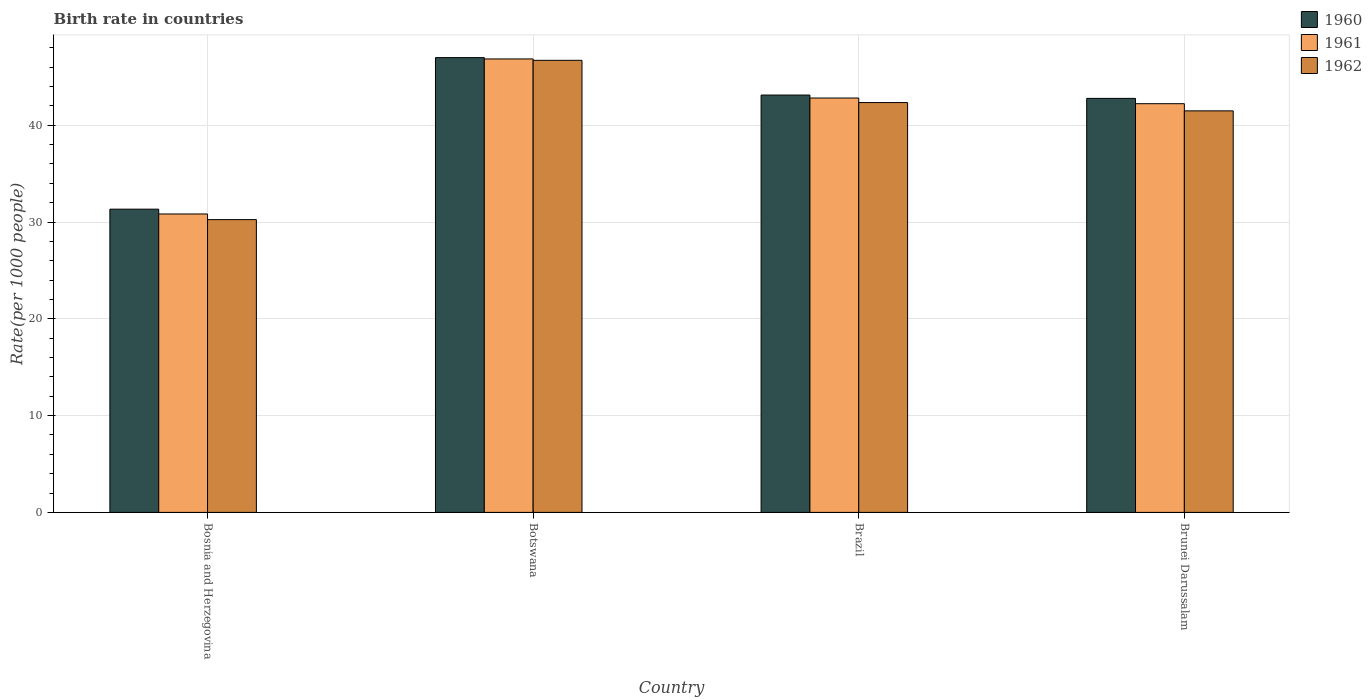How many groups of bars are there?
Provide a succinct answer. 4. Are the number of bars per tick equal to the number of legend labels?
Your answer should be compact. Yes. What is the label of the 1st group of bars from the left?
Keep it short and to the point. Bosnia and Herzegovina. What is the birth rate in 1962 in Botswana?
Your answer should be very brief. 46.71. Across all countries, what is the maximum birth rate in 1960?
Offer a terse response. 46.99. Across all countries, what is the minimum birth rate in 1960?
Ensure brevity in your answer.  31.33. In which country was the birth rate in 1962 maximum?
Offer a terse response. Botswana. In which country was the birth rate in 1960 minimum?
Make the answer very short. Bosnia and Herzegovina. What is the total birth rate in 1962 in the graph?
Make the answer very short. 160.8. What is the difference between the birth rate in 1960 in Botswana and that in Brunei Darussalam?
Make the answer very short. 4.21. What is the difference between the birth rate in 1961 in Bosnia and Herzegovina and the birth rate in 1960 in Brunei Darussalam?
Keep it short and to the point. -11.94. What is the average birth rate in 1960 per country?
Make the answer very short. 41.06. What is the difference between the birth rate of/in 1962 and birth rate of/in 1960 in Brazil?
Offer a very short reply. -0.78. In how many countries, is the birth rate in 1961 greater than 44?
Make the answer very short. 1. What is the ratio of the birth rate in 1960 in Brazil to that in Brunei Darussalam?
Give a very brief answer. 1.01. Is the birth rate in 1960 in Brazil less than that in Brunei Darussalam?
Ensure brevity in your answer.  No. What is the difference between the highest and the second highest birth rate in 1960?
Ensure brevity in your answer.  -0.34. What is the difference between the highest and the lowest birth rate in 1960?
Ensure brevity in your answer.  15.66. In how many countries, is the birth rate in 1962 greater than the average birth rate in 1962 taken over all countries?
Provide a short and direct response. 3. What does the 3rd bar from the right in Botswana represents?
Keep it short and to the point. 1960. How many bars are there?
Offer a terse response. 12. What is the difference between two consecutive major ticks on the Y-axis?
Offer a terse response. 10. Does the graph contain any zero values?
Offer a terse response. No. How many legend labels are there?
Ensure brevity in your answer.  3. How are the legend labels stacked?
Offer a terse response. Vertical. What is the title of the graph?
Give a very brief answer. Birth rate in countries. Does "1975" appear as one of the legend labels in the graph?
Your response must be concise. No. What is the label or title of the X-axis?
Your answer should be compact. Country. What is the label or title of the Y-axis?
Your answer should be compact. Rate(per 1000 people). What is the Rate(per 1000 people) of 1960 in Bosnia and Herzegovina?
Provide a succinct answer. 31.33. What is the Rate(per 1000 people) in 1961 in Bosnia and Herzegovina?
Provide a succinct answer. 30.84. What is the Rate(per 1000 people) of 1962 in Bosnia and Herzegovina?
Offer a terse response. 30.25. What is the Rate(per 1000 people) of 1960 in Botswana?
Ensure brevity in your answer.  46.99. What is the Rate(per 1000 people) of 1961 in Botswana?
Provide a short and direct response. 46.85. What is the Rate(per 1000 people) of 1962 in Botswana?
Provide a succinct answer. 46.71. What is the Rate(per 1000 people) in 1960 in Brazil?
Offer a very short reply. 43.12. What is the Rate(per 1000 people) of 1961 in Brazil?
Offer a terse response. 42.82. What is the Rate(per 1000 people) in 1962 in Brazil?
Keep it short and to the point. 42.35. What is the Rate(per 1000 people) in 1960 in Brunei Darussalam?
Your answer should be very brief. 42.78. What is the Rate(per 1000 people) of 1961 in Brunei Darussalam?
Keep it short and to the point. 42.23. What is the Rate(per 1000 people) of 1962 in Brunei Darussalam?
Keep it short and to the point. 41.49. Across all countries, what is the maximum Rate(per 1000 people) of 1960?
Your response must be concise. 46.99. Across all countries, what is the maximum Rate(per 1000 people) in 1961?
Your response must be concise. 46.85. Across all countries, what is the maximum Rate(per 1000 people) of 1962?
Provide a succinct answer. 46.71. Across all countries, what is the minimum Rate(per 1000 people) of 1960?
Your response must be concise. 31.33. Across all countries, what is the minimum Rate(per 1000 people) in 1961?
Your answer should be very brief. 30.84. Across all countries, what is the minimum Rate(per 1000 people) in 1962?
Your answer should be compact. 30.25. What is the total Rate(per 1000 people) of 1960 in the graph?
Offer a terse response. 164.23. What is the total Rate(per 1000 people) in 1961 in the graph?
Make the answer very short. 162.74. What is the total Rate(per 1000 people) in 1962 in the graph?
Provide a short and direct response. 160.8. What is the difference between the Rate(per 1000 people) of 1960 in Bosnia and Herzegovina and that in Botswana?
Offer a terse response. -15.66. What is the difference between the Rate(per 1000 people) of 1961 in Bosnia and Herzegovina and that in Botswana?
Your response must be concise. -16.02. What is the difference between the Rate(per 1000 people) of 1962 in Bosnia and Herzegovina and that in Botswana?
Keep it short and to the point. -16.46. What is the difference between the Rate(per 1000 people) of 1960 in Bosnia and Herzegovina and that in Brazil?
Offer a terse response. -11.79. What is the difference between the Rate(per 1000 people) of 1961 in Bosnia and Herzegovina and that in Brazil?
Make the answer very short. -11.98. What is the difference between the Rate(per 1000 people) in 1962 in Bosnia and Herzegovina and that in Brazil?
Offer a terse response. -12.09. What is the difference between the Rate(per 1000 people) of 1960 in Bosnia and Herzegovina and that in Brunei Darussalam?
Ensure brevity in your answer.  -11.45. What is the difference between the Rate(per 1000 people) in 1961 in Bosnia and Herzegovina and that in Brunei Darussalam?
Make the answer very short. -11.39. What is the difference between the Rate(per 1000 people) of 1962 in Bosnia and Herzegovina and that in Brunei Darussalam?
Your answer should be compact. -11.24. What is the difference between the Rate(per 1000 people) of 1960 in Botswana and that in Brazil?
Give a very brief answer. 3.87. What is the difference between the Rate(per 1000 people) of 1961 in Botswana and that in Brazil?
Give a very brief answer. 4.04. What is the difference between the Rate(per 1000 people) of 1962 in Botswana and that in Brazil?
Keep it short and to the point. 4.37. What is the difference between the Rate(per 1000 people) of 1960 in Botswana and that in Brunei Darussalam?
Your answer should be very brief. 4.21. What is the difference between the Rate(per 1000 people) in 1961 in Botswana and that in Brunei Darussalam?
Ensure brevity in your answer.  4.62. What is the difference between the Rate(per 1000 people) of 1962 in Botswana and that in Brunei Darussalam?
Offer a terse response. 5.22. What is the difference between the Rate(per 1000 people) in 1960 in Brazil and that in Brunei Darussalam?
Offer a very short reply. 0.34. What is the difference between the Rate(per 1000 people) of 1961 in Brazil and that in Brunei Darussalam?
Your response must be concise. 0.59. What is the difference between the Rate(per 1000 people) of 1962 in Brazil and that in Brunei Darussalam?
Offer a terse response. 0.86. What is the difference between the Rate(per 1000 people) of 1960 in Bosnia and Herzegovina and the Rate(per 1000 people) of 1961 in Botswana?
Your answer should be very brief. -15.52. What is the difference between the Rate(per 1000 people) in 1960 in Bosnia and Herzegovina and the Rate(per 1000 people) in 1962 in Botswana?
Your answer should be very brief. -15.38. What is the difference between the Rate(per 1000 people) in 1961 in Bosnia and Herzegovina and the Rate(per 1000 people) in 1962 in Botswana?
Offer a very short reply. -15.88. What is the difference between the Rate(per 1000 people) of 1960 in Bosnia and Herzegovina and the Rate(per 1000 people) of 1961 in Brazil?
Offer a terse response. -11.48. What is the difference between the Rate(per 1000 people) in 1960 in Bosnia and Herzegovina and the Rate(per 1000 people) in 1962 in Brazil?
Your answer should be very brief. -11.01. What is the difference between the Rate(per 1000 people) of 1961 in Bosnia and Herzegovina and the Rate(per 1000 people) of 1962 in Brazil?
Keep it short and to the point. -11.51. What is the difference between the Rate(per 1000 people) of 1960 in Bosnia and Herzegovina and the Rate(per 1000 people) of 1961 in Brunei Darussalam?
Your response must be concise. -10.9. What is the difference between the Rate(per 1000 people) in 1960 in Bosnia and Herzegovina and the Rate(per 1000 people) in 1962 in Brunei Darussalam?
Provide a short and direct response. -10.16. What is the difference between the Rate(per 1000 people) of 1961 in Bosnia and Herzegovina and the Rate(per 1000 people) of 1962 in Brunei Darussalam?
Your answer should be compact. -10.65. What is the difference between the Rate(per 1000 people) of 1960 in Botswana and the Rate(per 1000 people) of 1961 in Brazil?
Provide a succinct answer. 4.18. What is the difference between the Rate(per 1000 people) in 1960 in Botswana and the Rate(per 1000 people) in 1962 in Brazil?
Make the answer very short. 4.65. What is the difference between the Rate(per 1000 people) in 1961 in Botswana and the Rate(per 1000 people) in 1962 in Brazil?
Offer a very short reply. 4.51. What is the difference between the Rate(per 1000 people) of 1960 in Botswana and the Rate(per 1000 people) of 1961 in Brunei Darussalam?
Make the answer very short. 4.76. What is the difference between the Rate(per 1000 people) of 1960 in Botswana and the Rate(per 1000 people) of 1962 in Brunei Darussalam?
Offer a terse response. 5.5. What is the difference between the Rate(per 1000 people) of 1961 in Botswana and the Rate(per 1000 people) of 1962 in Brunei Darussalam?
Your answer should be very brief. 5.37. What is the difference between the Rate(per 1000 people) in 1960 in Brazil and the Rate(per 1000 people) in 1961 in Brunei Darussalam?
Offer a terse response. 0.89. What is the difference between the Rate(per 1000 people) of 1960 in Brazil and the Rate(per 1000 people) of 1962 in Brunei Darussalam?
Give a very brief answer. 1.63. What is the difference between the Rate(per 1000 people) in 1961 in Brazil and the Rate(per 1000 people) in 1962 in Brunei Darussalam?
Provide a short and direct response. 1.33. What is the average Rate(per 1000 people) in 1960 per country?
Your response must be concise. 41.06. What is the average Rate(per 1000 people) in 1961 per country?
Offer a terse response. 40.68. What is the average Rate(per 1000 people) in 1962 per country?
Your response must be concise. 40.2. What is the difference between the Rate(per 1000 people) of 1960 and Rate(per 1000 people) of 1961 in Bosnia and Herzegovina?
Your answer should be very brief. 0.5. What is the difference between the Rate(per 1000 people) of 1960 and Rate(per 1000 people) of 1962 in Bosnia and Herzegovina?
Offer a terse response. 1.08. What is the difference between the Rate(per 1000 people) in 1961 and Rate(per 1000 people) in 1962 in Bosnia and Herzegovina?
Ensure brevity in your answer.  0.58. What is the difference between the Rate(per 1000 people) in 1960 and Rate(per 1000 people) in 1961 in Botswana?
Your answer should be compact. 0.14. What is the difference between the Rate(per 1000 people) in 1960 and Rate(per 1000 people) in 1962 in Botswana?
Offer a terse response. 0.28. What is the difference between the Rate(per 1000 people) of 1961 and Rate(per 1000 people) of 1962 in Botswana?
Make the answer very short. 0.14. What is the difference between the Rate(per 1000 people) in 1960 and Rate(per 1000 people) in 1961 in Brazil?
Provide a succinct answer. 0.31. What is the difference between the Rate(per 1000 people) of 1960 and Rate(per 1000 people) of 1962 in Brazil?
Ensure brevity in your answer.  0.78. What is the difference between the Rate(per 1000 people) in 1961 and Rate(per 1000 people) in 1962 in Brazil?
Provide a short and direct response. 0.47. What is the difference between the Rate(per 1000 people) in 1960 and Rate(per 1000 people) in 1961 in Brunei Darussalam?
Make the answer very short. 0.55. What is the difference between the Rate(per 1000 people) in 1960 and Rate(per 1000 people) in 1962 in Brunei Darussalam?
Make the answer very short. 1.29. What is the difference between the Rate(per 1000 people) in 1961 and Rate(per 1000 people) in 1962 in Brunei Darussalam?
Give a very brief answer. 0.74. What is the ratio of the Rate(per 1000 people) in 1960 in Bosnia and Herzegovina to that in Botswana?
Offer a terse response. 0.67. What is the ratio of the Rate(per 1000 people) in 1961 in Bosnia and Herzegovina to that in Botswana?
Your answer should be very brief. 0.66. What is the ratio of the Rate(per 1000 people) in 1962 in Bosnia and Herzegovina to that in Botswana?
Provide a short and direct response. 0.65. What is the ratio of the Rate(per 1000 people) of 1960 in Bosnia and Herzegovina to that in Brazil?
Provide a succinct answer. 0.73. What is the ratio of the Rate(per 1000 people) in 1961 in Bosnia and Herzegovina to that in Brazil?
Give a very brief answer. 0.72. What is the ratio of the Rate(per 1000 people) in 1962 in Bosnia and Herzegovina to that in Brazil?
Your response must be concise. 0.71. What is the ratio of the Rate(per 1000 people) of 1960 in Bosnia and Herzegovina to that in Brunei Darussalam?
Keep it short and to the point. 0.73. What is the ratio of the Rate(per 1000 people) of 1961 in Bosnia and Herzegovina to that in Brunei Darussalam?
Your answer should be very brief. 0.73. What is the ratio of the Rate(per 1000 people) of 1962 in Bosnia and Herzegovina to that in Brunei Darussalam?
Your answer should be very brief. 0.73. What is the ratio of the Rate(per 1000 people) of 1960 in Botswana to that in Brazil?
Your answer should be very brief. 1.09. What is the ratio of the Rate(per 1000 people) of 1961 in Botswana to that in Brazil?
Offer a very short reply. 1.09. What is the ratio of the Rate(per 1000 people) in 1962 in Botswana to that in Brazil?
Your response must be concise. 1.1. What is the ratio of the Rate(per 1000 people) of 1960 in Botswana to that in Brunei Darussalam?
Ensure brevity in your answer.  1.1. What is the ratio of the Rate(per 1000 people) in 1961 in Botswana to that in Brunei Darussalam?
Give a very brief answer. 1.11. What is the ratio of the Rate(per 1000 people) in 1962 in Botswana to that in Brunei Darussalam?
Provide a short and direct response. 1.13. What is the ratio of the Rate(per 1000 people) in 1961 in Brazil to that in Brunei Darussalam?
Offer a very short reply. 1.01. What is the ratio of the Rate(per 1000 people) in 1962 in Brazil to that in Brunei Darussalam?
Your answer should be compact. 1.02. What is the difference between the highest and the second highest Rate(per 1000 people) in 1960?
Your response must be concise. 3.87. What is the difference between the highest and the second highest Rate(per 1000 people) of 1961?
Make the answer very short. 4.04. What is the difference between the highest and the second highest Rate(per 1000 people) in 1962?
Ensure brevity in your answer.  4.37. What is the difference between the highest and the lowest Rate(per 1000 people) of 1960?
Ensure brevity in your answer.  15.66. What is the difference between the highest and the lowest Rate(per 1000 people) in 1961?
Make the answer very short. 16.02. What is the difference between the highest and the lowest Rate(per 1000 people) of 1962?
Your answer should be very brief. 16.46. 